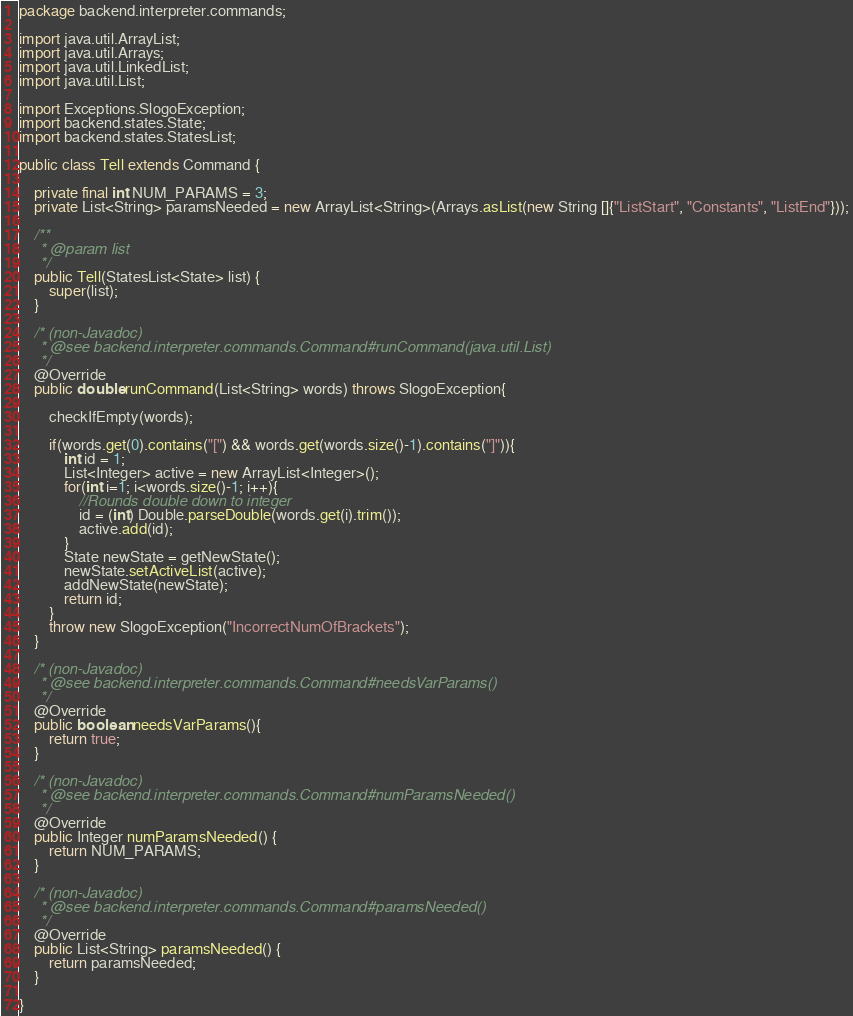<code> <loc_0><loc_0><loc_500><loc_500><_Java_>package backend.interpreter.commands;

import java.util.ArrayList;
import java.util.Arrays;
import java.util.LinkedList;
import java.util.List;

import Exceptions.SlogoException;
import backend.states.State;
import backend.states.StatesList;

public class Tell extends Command {
	
	private final int NUM_PARAMS = 3;
	private List<String> paramsNeeded = new ArrayList<String>(Arrays.asList(new String []{"ListStart", "Constants", "ListEnd"}));
	
	/**
	 * @param list
	 */
	public Tell(StatesList<State> list) {
		super(list);
	}
	
	/* (non-Javadoc)
	 * @see backend.interpreter.commands.Command#runCommand(java.util.List)
	 */
	@Override
	public double runCommand(List<String> words) throws SlogoException{
	
		checkIfEmpty(words);
		
		if(words.get(0).contains("[") && words.get(words.size()-1).contains("]")){
			int id = 1;
			List<Integer> active = new ArrayList<Integer>();
			for(int i=1; i<words.size()-1; i++){
				//Rounds double down to integer
				id = (int) Double.parseDouble(words.get(i).trim());
				active.add(id);
			}
			State newState = getNewState();
			newState.setActiveList(active);
			addNewState(newState);
			return id;
		}	
		throw new SlogoException("IncorrectNumOfBrackets");
	}	
		
	/* (non-Javadoc)
	 * @see backend.interpreter.commands.Command#needsVarParams()
	 */
	@Override
	public boolean needsVarParams(){
		return true;
	}

	/* (non-Javadoc)
	 * @see backend.interpreter.commands.Command#numParamsNeeded()
	 */
	@Override
	public Integer numParamsNeeded() {
		return NUM_PARAMS;
	}

	/* (non-Javadoc)
	 * @see backend.interpreter.commands.Command#paramsNeeded()
	 */
	@Override
	public List<String> paramsNeeded() {
		return paramsNeeded;
	}

}
</code> 